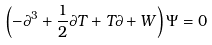Convert formula to latex. <formula><loc_0><loc_0><loc_500><loc_500>\left ( - \partial ^ { 3 } + \frac { 1 } { 2 } \partial T + T \partial + W \right ) \Psi = 0</formula> 